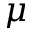Convert formula to latex. <formula><loc_0><loc_0><loc_500><loc_500>\mu</formula> 